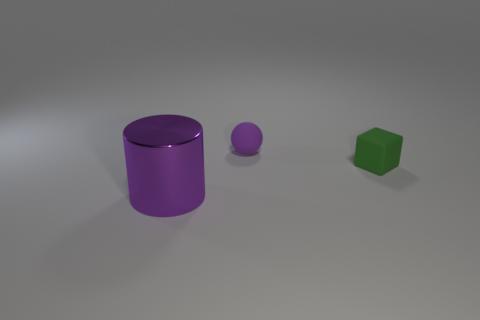Is there anything about this image that suggests it might be used in a specific context? The simplicity and cleanliness of the image suggest it could be used in an educational or illustrative context, perhaps to teach about colors, shapes, or spatial relations. 